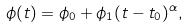<formula> <loc_0><loc_0><loc_500><loc_500>\phi ( t ) = \phi _ { 0 } + \phi _ { 1 } ( t - t _ { 0 } ) ^ { \alpha } ,</formula> 